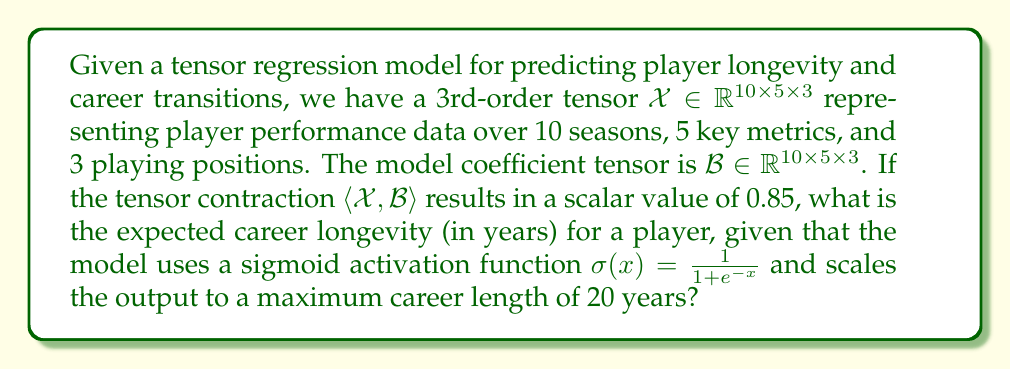Help me with this question. To solve this problem, we'll follow these steps:

1) The tensor contraction $\langle \mathcal{X}, \mathcal{B} \rangle$ results in a scalar value of 0.85. This is the input to our sigmoid activation function.

2) We need to apply the sigmoid function to this value:

   $\sigma(0.85) = \frac{1}{1 + e^{-0.85}}$

3) Let's calculate this:
   
   $\sigma(0.85) = \frac{1}{1 + e^{-0.85}} \approx 0.7006$

4) The sigmoid function outputs a value between 0 and 1. This needs to be scaled to our maximum career length of 20 years.

5) To scale the output, we multiply the sigmoid result by 20:

   $0.7006 \times 20 \approx 14.012$

Therefore, the expected career longevity for the player is approximately 14.012 years.
Answer: 14.012 years 